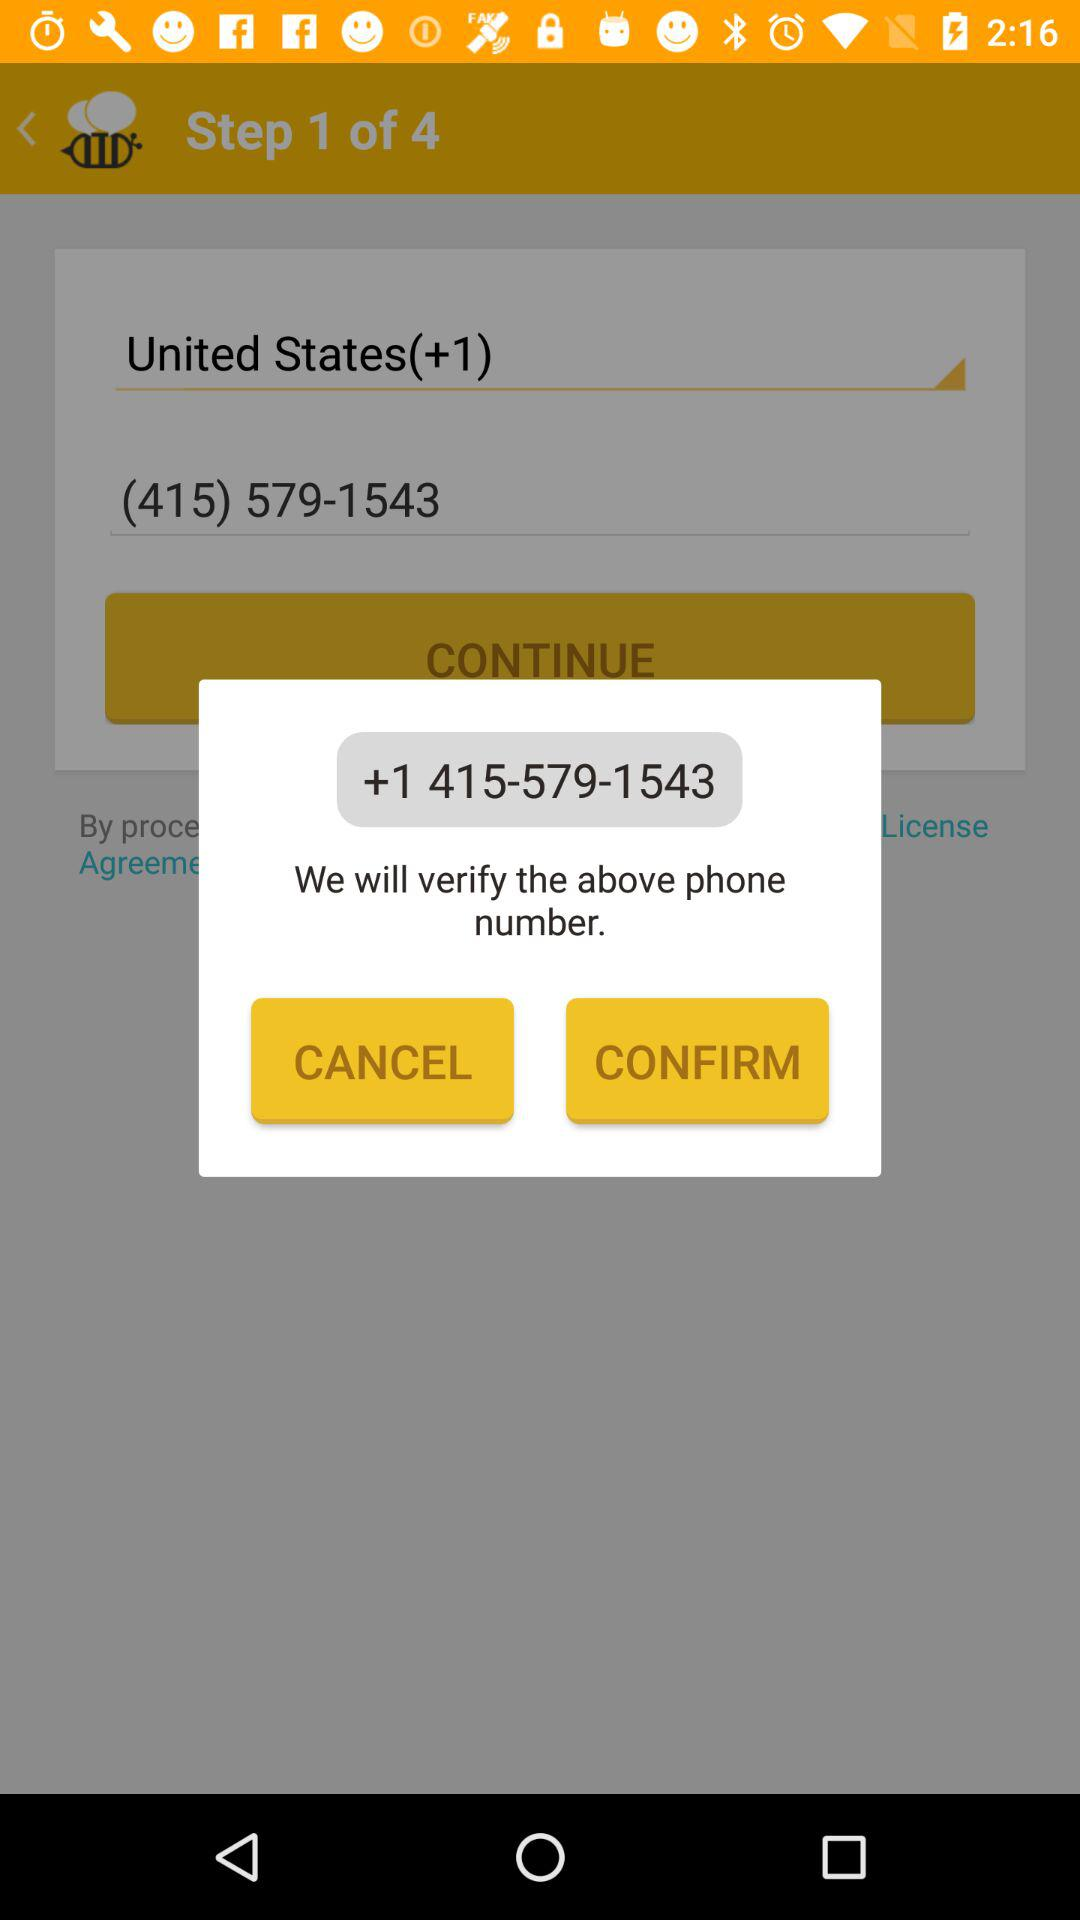Has the user agreed to the terms of service and privacy policy?
When the provided information is insufficient, respond with <no answer>. <no answer> 